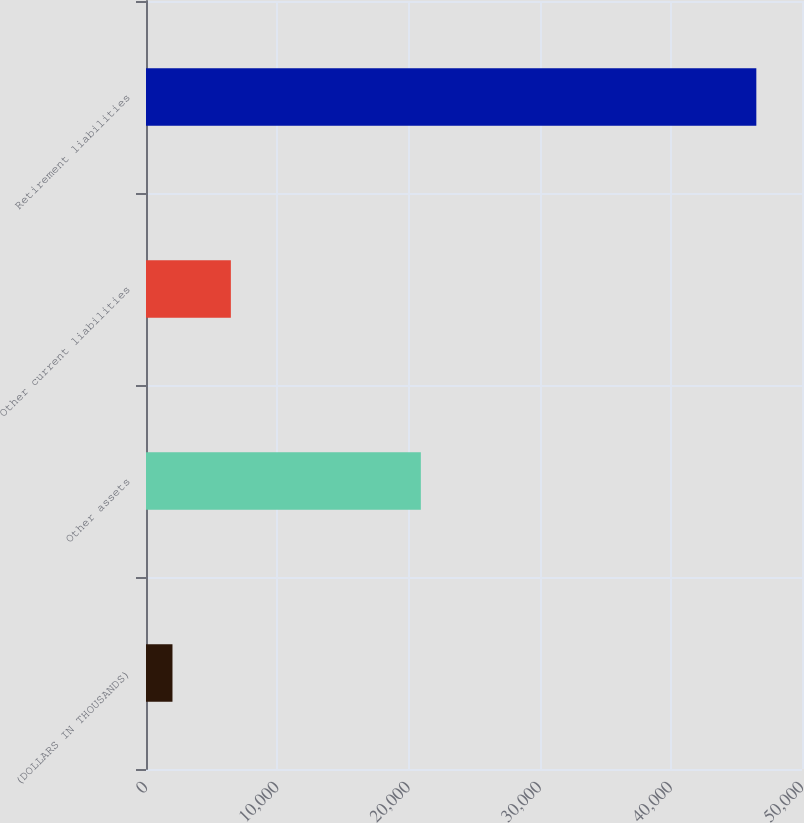<chart> <loc_0><loc_0><loc_500><loc_500><bar_chart><fcel>(DOLLARS IN THOUSANDS)<fcel>Other assets<fcel>Other current liabilities<fcel>Retirement liabilities<nl><fcel>2018<fcel>20949<fcel>6468.1<fcel>46519<nl></chart> 